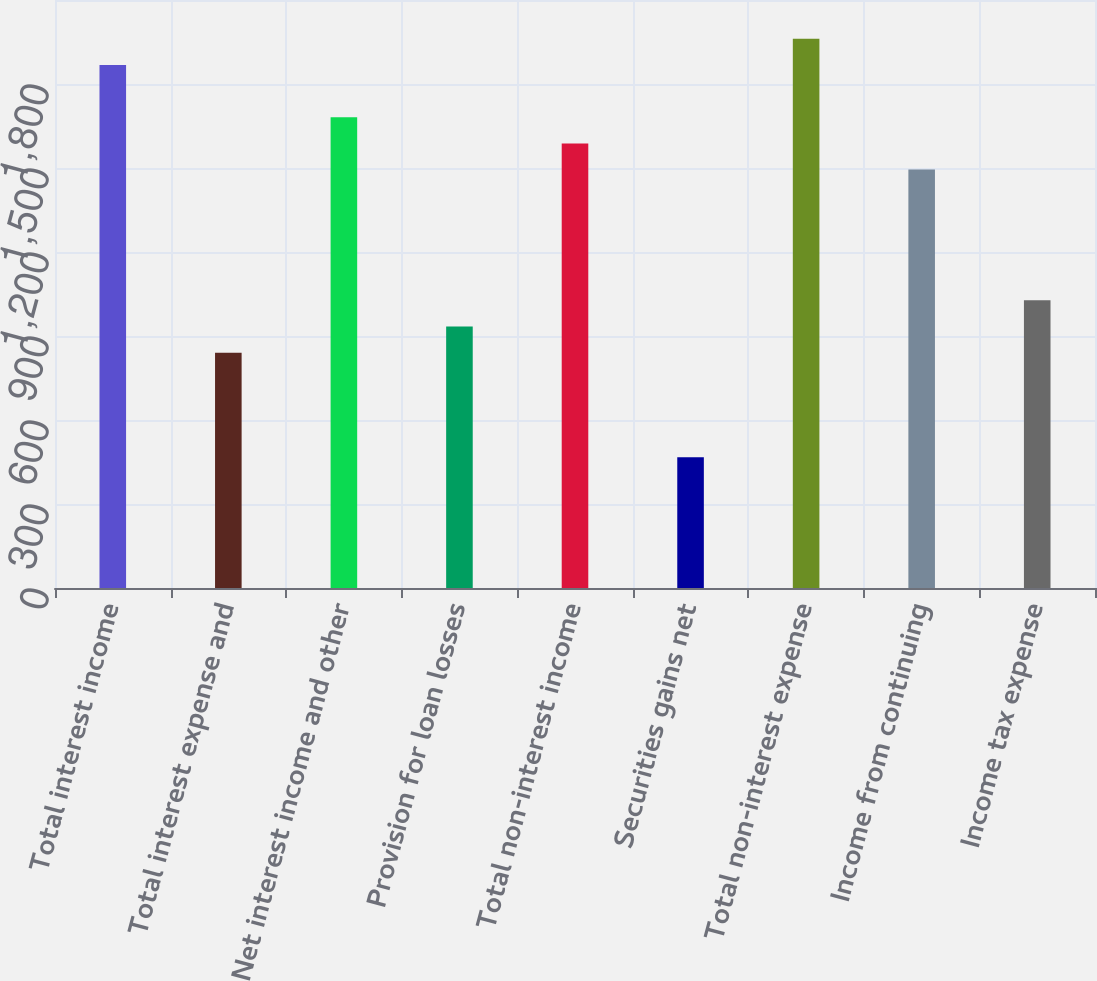<chart> <loc_0><loc_0><loc_500><loc_500><bar_chart><fcel>Total interest income<fcel>Total interest expense and<fcel>Net interest income and other<fcel>Provision for loan losses<fcel>Total non-interest income<fcel>Securities gains net<fcel>Total non-interest expense<fcel>Income from continuing<fcel>Income tax expense<nl><fcel>1867.86<fcel>840.57<fcel>1681.08<fcel>933.96<fcel>1587.69<fcel>467.01<fcel>1961.25<fcel>1494.3<fcel>1027.35<nl></chart> 